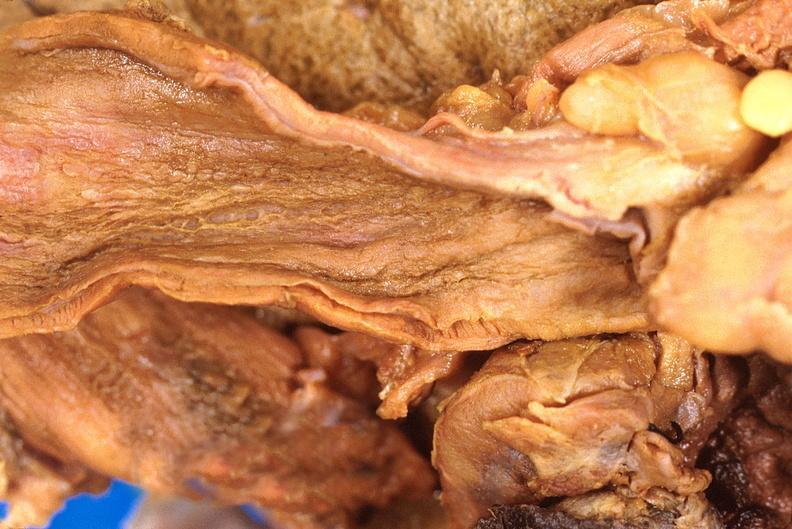does this image show stomach, necrotizing esophagitis and gastritis, sulfuric acid ingested as suicide attempt?
Answer the question using a single word or phrase. Yes 